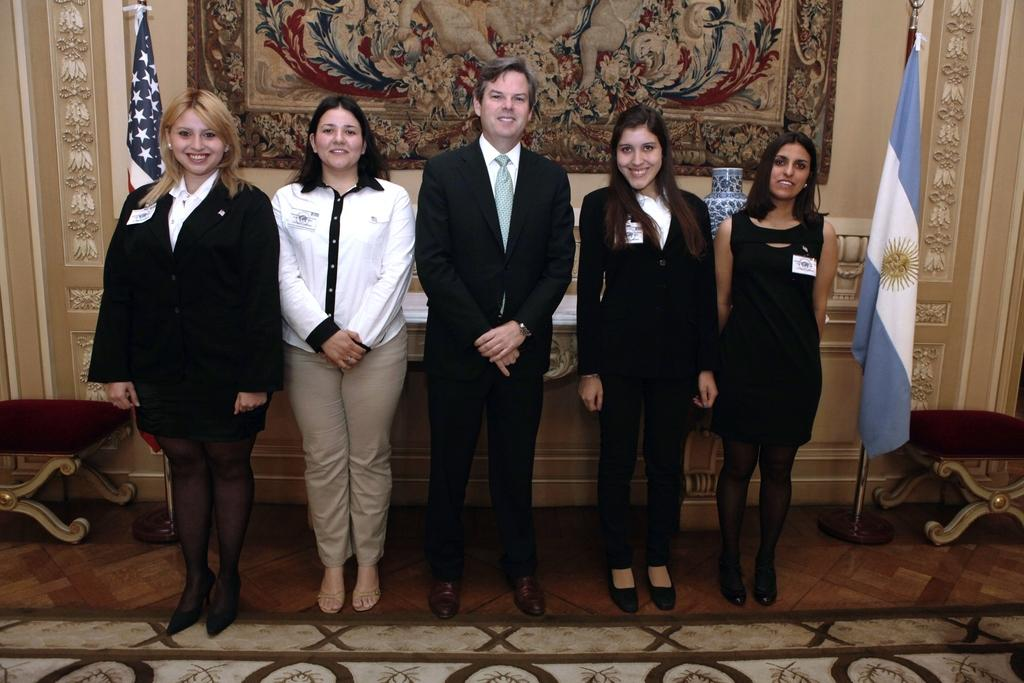Who or what is present in the image? There are people in the image. What object can be seen on a table in the image? There is a vase on a table in the image. What type of furniture is visible in the image? There are chairs in the image. What decorative elements are present in the image? There are flags in the image. What type of wall design can be seen in the image? There is a designed wall in the image. What type of feast is being prepared in the image? There is no indication of a feast being prepared in the image. Can you describe the people running in the image? There are no people running in the image; the people are stationary. 